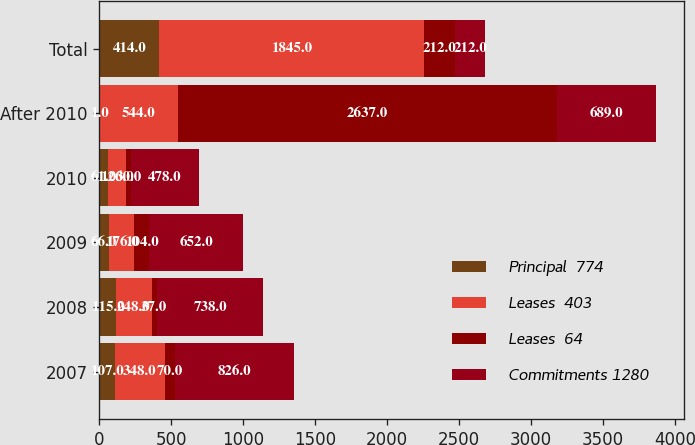Convert chart. <chart><loc_0><loc_0><loc_500><loc_500><stacked_bar_chart><ecel><fcel>2007<fcel>2008<fcel>2009<fcel>2010<fcel>After 2010<fcel>Total<nl><fcel>Principal  774<fcel>107<fcel>115<fcel>66<fcel>61<fcel>1<fcel>414<nl><fcel>Leases  403<fcel>348<fcel>248<fcel>176<fcel>126<fcel>544<fcel>1845<nl><fcel>Leases  64<fcel>70<fcel>37<fcel>104<fcel>30<fcel>2637<fcel>212<nl><fcel>Commitments 1280<fcel>826<fcel>738<fcel>652<fcel>478<fcel>689<fcel>212<nl></chart> 